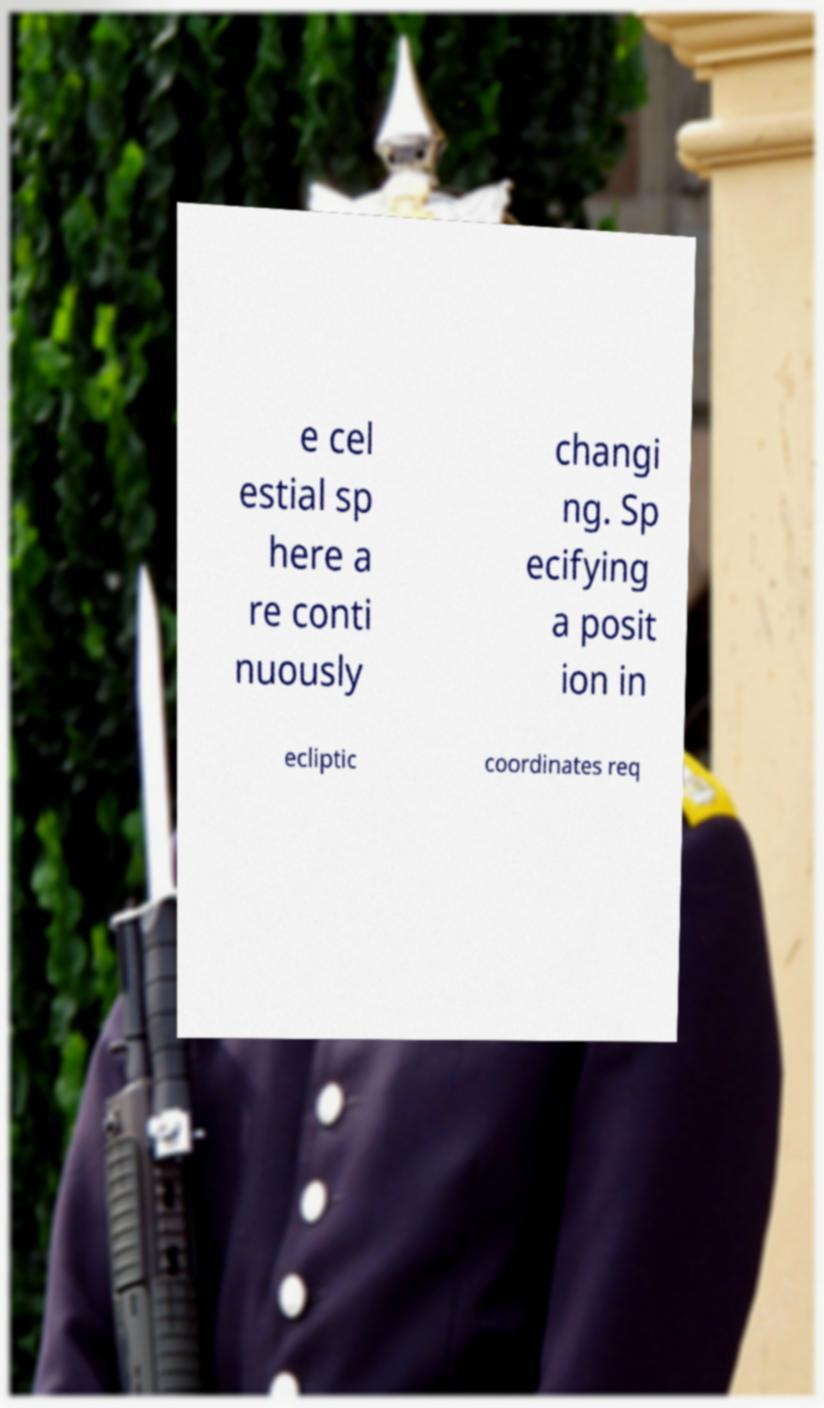What messages or text are displayed in this image? I need them in a readable, typed format. e cel estial sp here a re conti nuously changi ng. Sp ecifying a posit ion in ecliptic coordinates req 